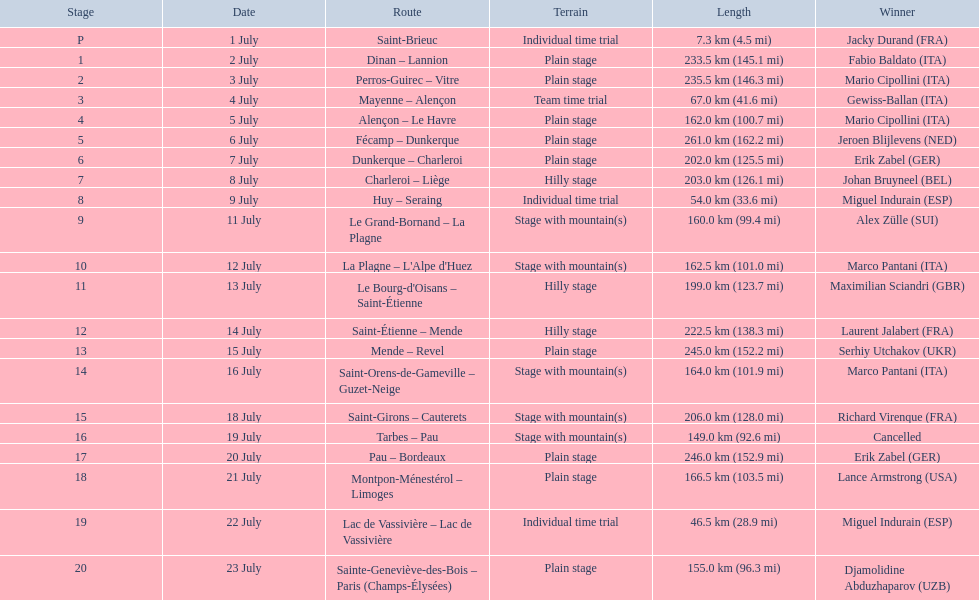What were the specific dates of the 1995 tour de france? 1 July, 2 July, 3 July, 4 July, 5 July, 6 July, 7 July, 8 July, 9 July, 11 July, 12 July, 13 July, 14 July, 15 July, 16 July, 18 July, 19 July, 20 July, 21 July, 22 July, 23 July. What was the distance covered on july 8th? 203.0 km (126.1 mi). 